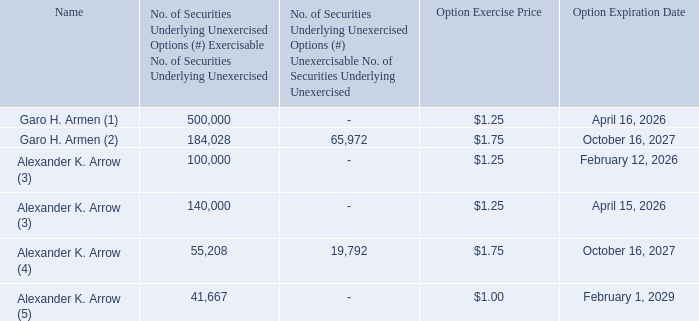Outstanding Equity Awards at Fiscal Year End
The following table summarizes the equity awards made to our named executive officers that were outstanding at December 31, 2019
How many of Garo H. Armen's options would expire on April 15, 2026?  500,000. How many of Garo H. Armen's options would expire on October 16, 2027? 184,028. How many of Alexander K. Arrow's options would expire n April 15, 2026? 140,000. How many options would expire on April 15, 2026? 500,000 + 140,000 
Answer: 640000. How many options would expire on October 16, 2027? 184,028 + 55,208 
Answer: 239236. How many unexercised options does Garo H. Armen have as at December 31, 2019? 500,000 + 184,028 
Answer: 684028. 